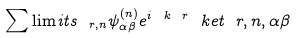Convert formula to latex. <formula><loc_0><loc_0><loc_500><loc_500>\sum \lim i t s _ { \ r , n } \psi _ { \alpha \beta } ^ { ( n ) } e ^ { i \ k \ r } \ k e t { \ r , n , \alpha \beta }</formula> 